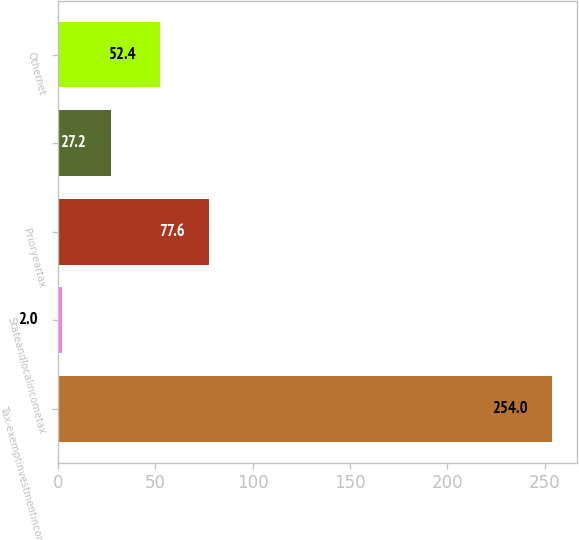Convert chart. <chart><loc_0><loc_0><loc_500><loc_500><bar_chart><fcel>Tax-exemptinvestmentincome<fcel>Stateandlocalincometax<fcel>Prioryeartax<fcel>Unnamed: 3<fcel>Othernet<nl><fcel>254<fcel>2<fcel>77.6<fcel>27.2<fcel>52.4<nl></chart> 